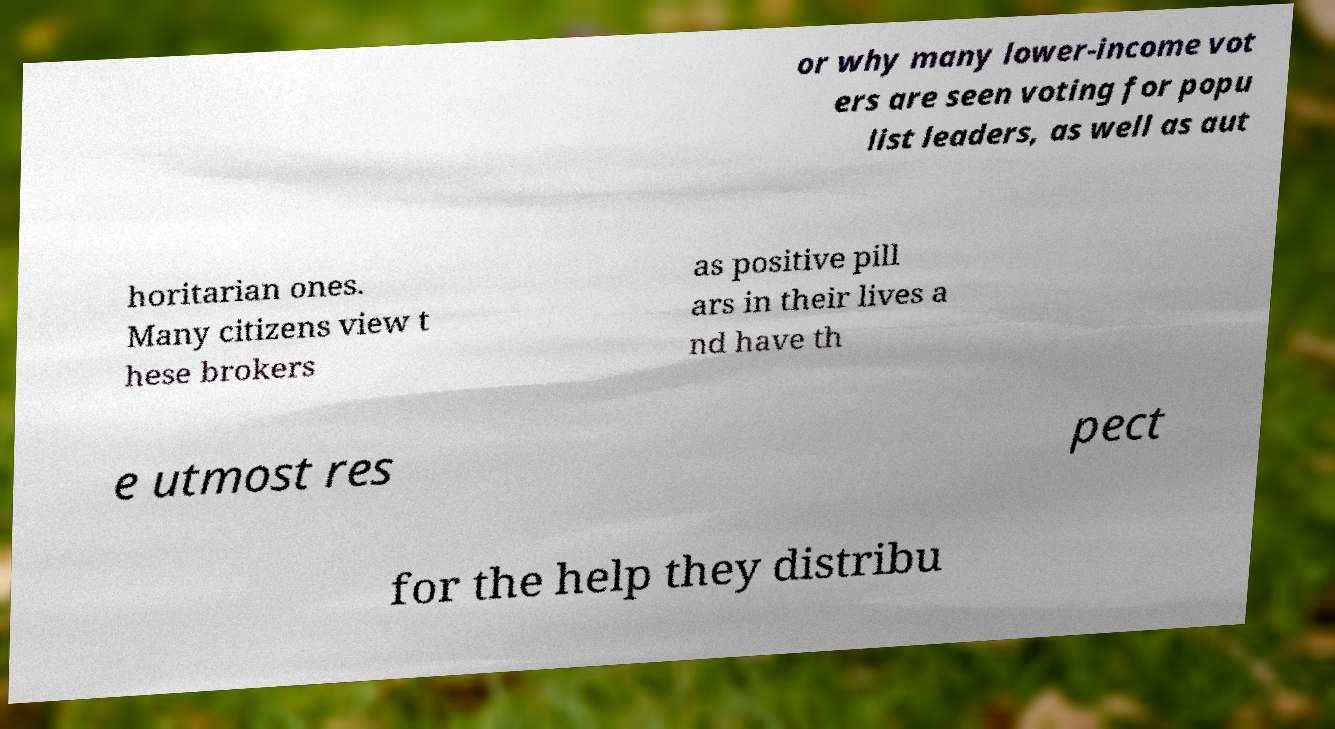Can you read and provide the text displayed in the image?This photo seems to have some interesting text. Can you extract and type it out for me? or why many lower-income vot ers are seen voting for popu list leaders, as well as aut horitarian ones. Many citizens view t hese brokers as positive pill ars in their lives a nd have th e utmost res pect for the help they distribu 